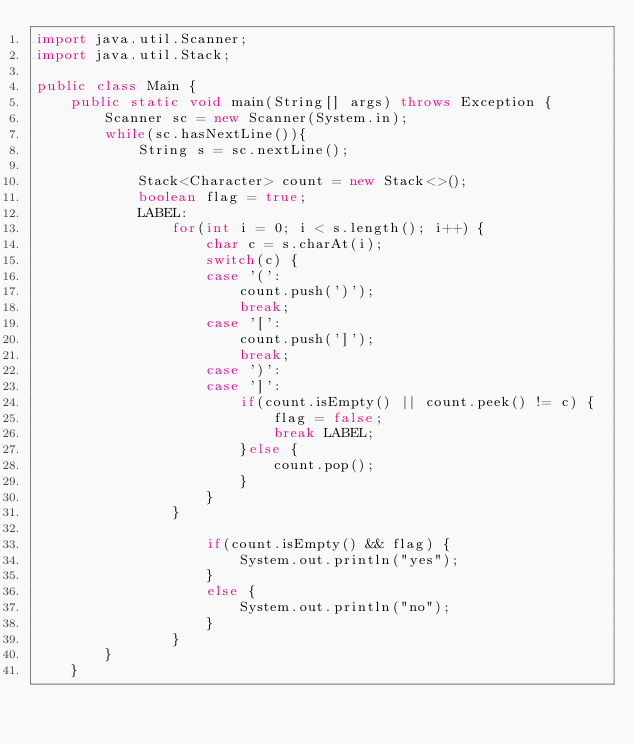Convert code to text. <code><loc_0><loc_0><loc_500><loc_500><_Java_>import java.util.Scanner;
import java.util.Stack;

public class Main {
	public static void main(String[] args) throws Exception {
		Scanner sc = new Scanner(System.in);
		while(sc.hasNextLine()){
			String s = sc.nextLine();
			
			Stack<Character> count = new Stack<>(); 
			boolean flag = true;
			LABEL:
				for(int i = 0; i < s.length(); i++) {
					char c = s.charAt(i);
					switch(c) {
					case '(':
						count.push(')');
						break;
					case '[':
						count.push(']');
						break;
					case ')':
					case ']':
						if(count.isEmpty() || count.peek() != c) {
							flag = false;
							break LABEL;
						}else {
							count.pop();
						}
					}
				}

					if(count.isEmpty() && flag) {
						System.out.println("yes");
					}
					else {
						System.out.println("no");
					}
				}
		}	
	}





</code> 